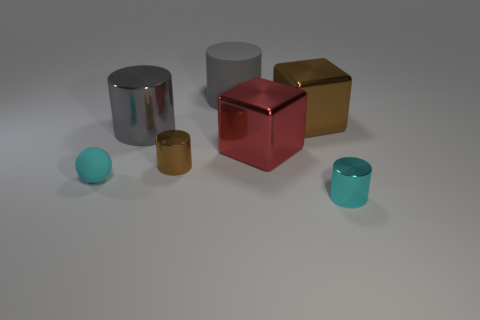Subtract all gray metallic cylinders. How many cylinders are left? 3 Subtract all blocks. How many objects are left? 5 Add 3 tiny cyan matte spheres. How many objects exist? 10 Subtract all red blocks. How many blocks are left? 1 Subtract all cyan balls. How many gray cylinders are left? 2 Subtract 1 cylinders. How many cylinders are left? 3 Subtract all purple blocks. Subtract all brown balls. How many blocks are left? 2 Subtract all tiny cyan matte things. Subtract all small cyan objects. How many objects are left? 4 Add 5 cyan matte objects. How many cyan matte objects are left? 6 Add 5 brown cubes. How many brown cubes exist? 6 